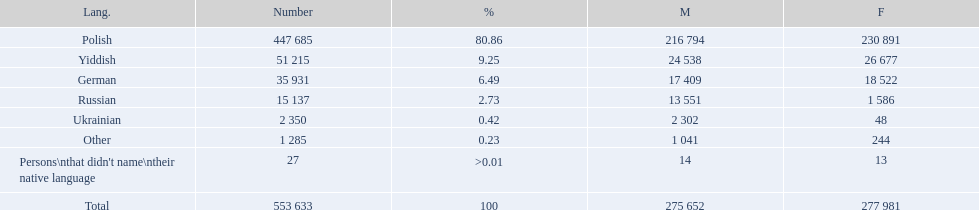How many languages have a name that is derived from a country? 4. 